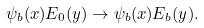Convert formula to latex. <formula><loc_0><loc_0><loc_500><loc_500>\psi _ { b } ( x ) E _ { 0 } ( y ) \rightarrow \psi _ { b } ( x ) E _ { b } ( y ) .</formula> 